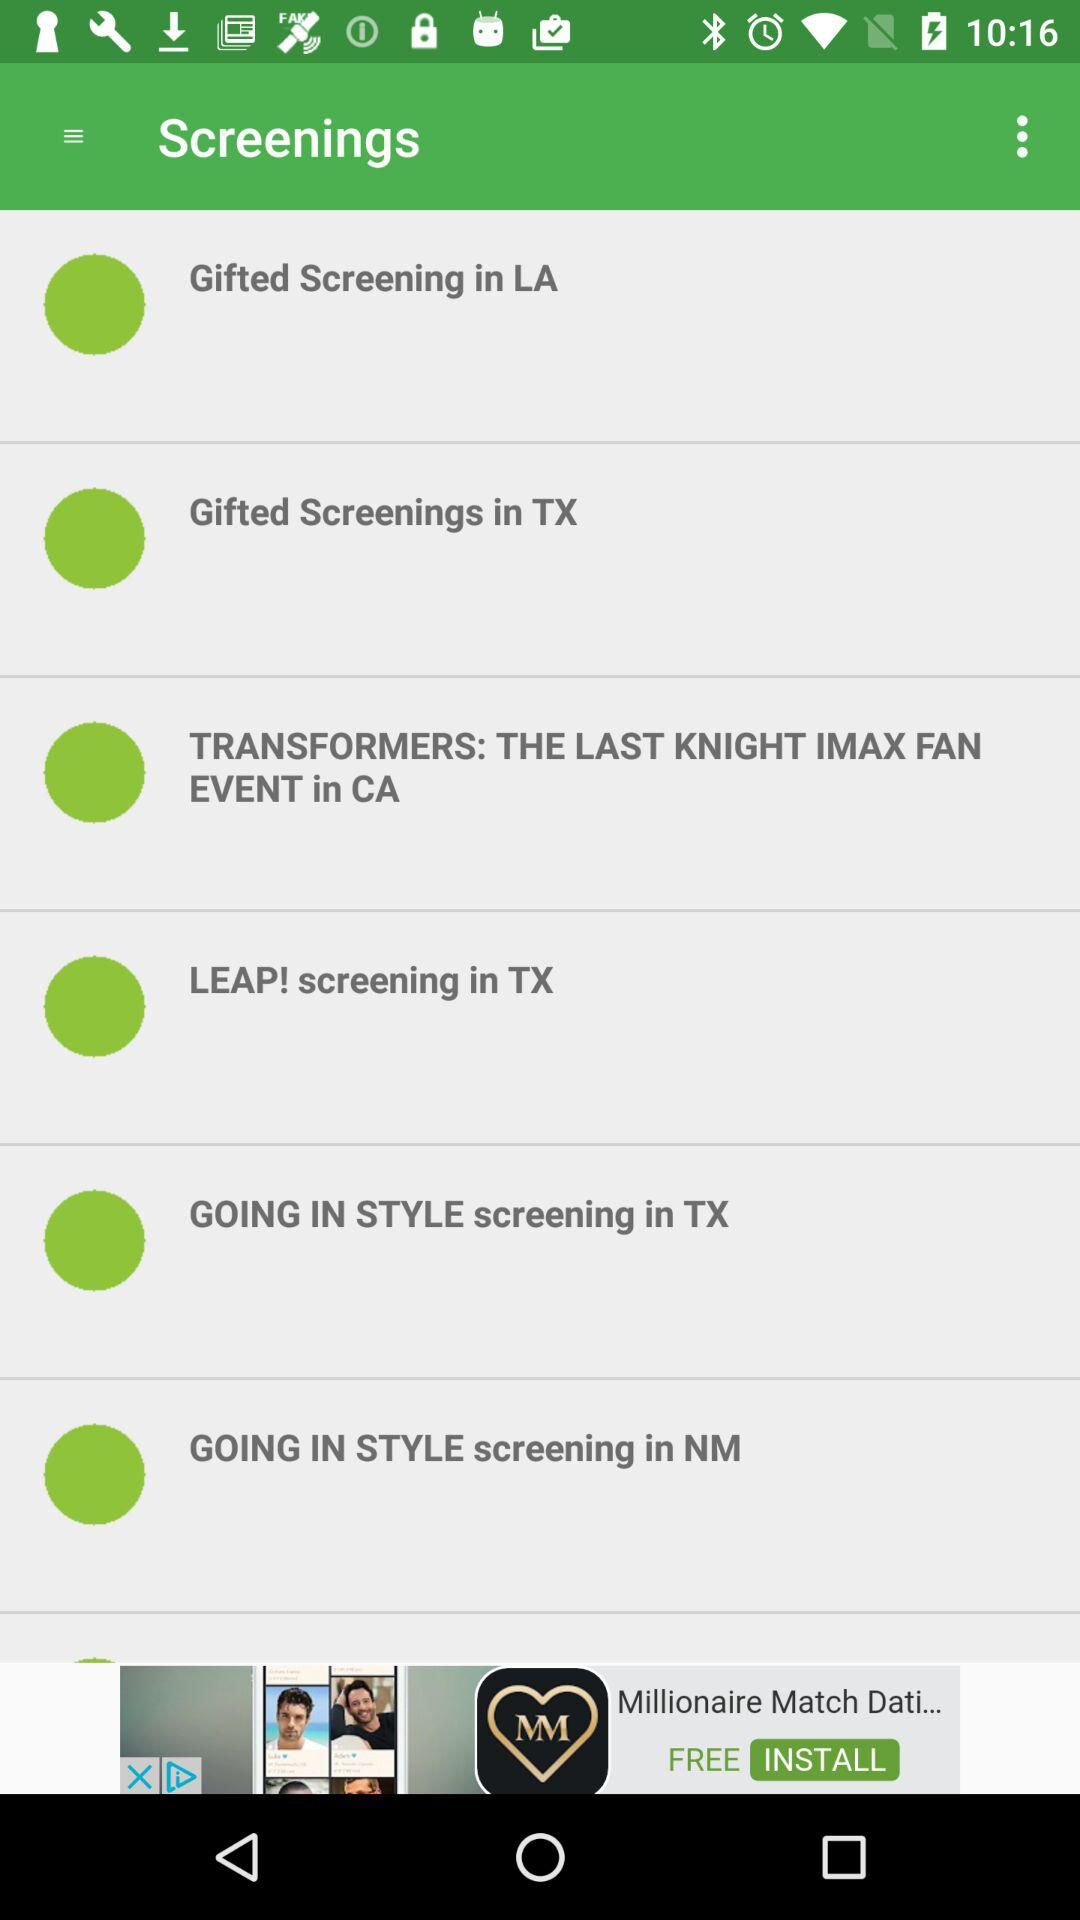Where is the "Gifted" screening? It is screening in LA and TX. 